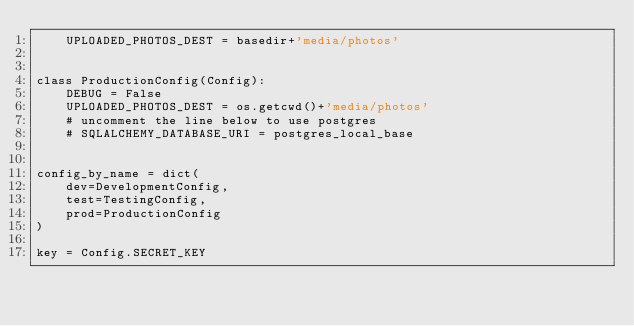Convert code to text. <code><loc_0><loc_0><loc_500><loc_500><_Python_>    UPLOADED_PHOTOS_DEST = basedir+'media/photos'


class ProductionConfig(Config):
    DEBUG = False
    UPLOADED_PHOTOS_DEST = os.getcwd()+'media/photos'
    # uncomment the line below to use postgres
    # SQLALCHEMY_DATABASE_URI = postgres_local_base


config_by_name = dict(
    dev=DevelopmentConfig,
    test=TestingConfig,
    prod=ProductionConfig
)

key = Config.SECRET_KEY</code> 